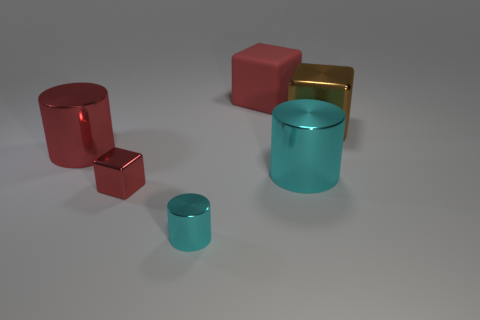Add 4 red things. How many objects exist? 10 Add 2 big metallic things. How many big metallic things are left? 5 Add 6 red rubber objects. How many red rubber objects exist? 7 Subtract 0 gray balls. How many objects are left? 6 Subtract all purple shiny cylinders. Subtract all matte cubes. How many objects are left? 5 